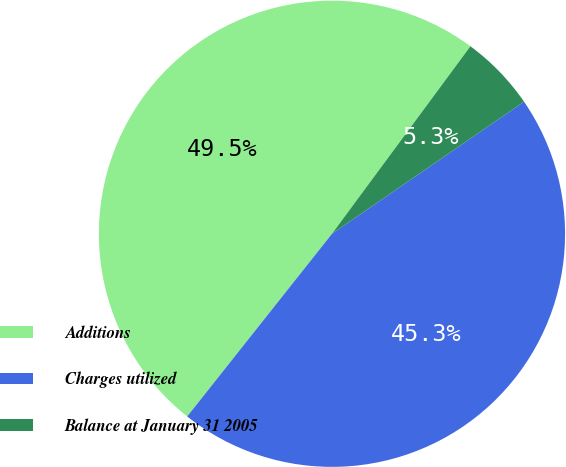Convert chart. <chart><loc_0><loc_0><loc_500><loc_500><pie_chart><fcel>Additions<fcel>Charges utilized<fcel>Balance at January 31 2005<nl><fcel>49.46%<fcel>45.26%<fcel>5.29%<nl></chart> 